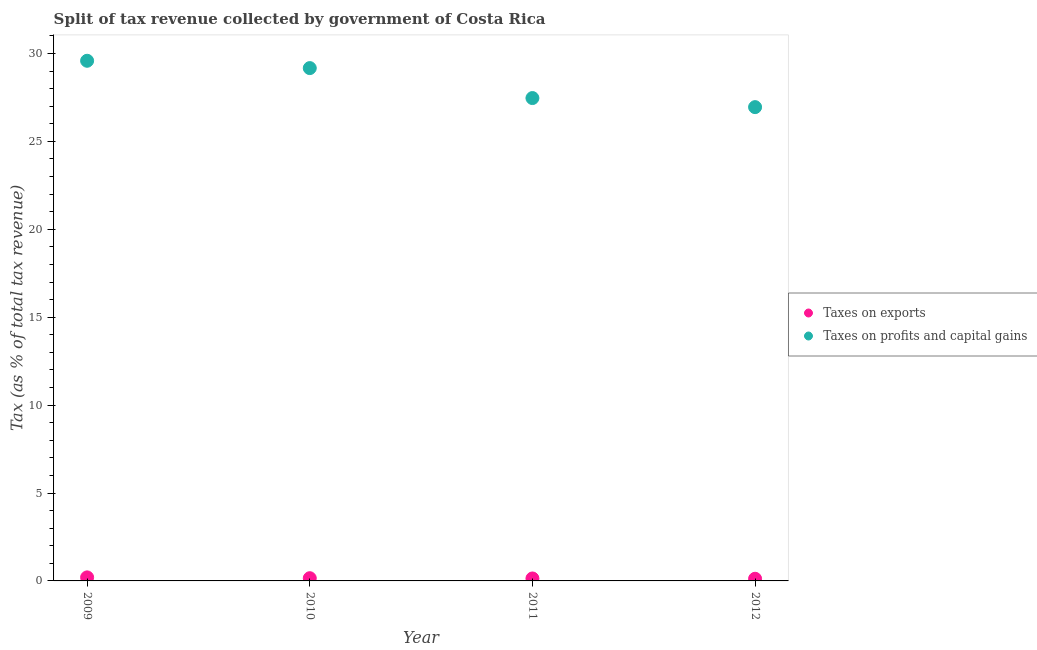How many different coloured dotlines are there?
Make the answer very short. 2. What is the percentage of revenue obtained from taxes on exports in 2010?
Your response must be concise. 0.15. Across all years, what is the maximum percentage of revenue obtained from taxes on profits and capital gains?
Your answer should be compact. 29.58. Across all years, what is the minimum percentage of revenue obtained from taxes on profits and capital gains?
Provide a succinct answer. 26.95. In which year was the percentage of revenue obtained from taxes on exports minimum?
Your answer should be very brief. 2012. What is the total percentage of revenue obtained from taxes on profits and capital gains in the graph?
Offer a very short reply. 113.16. What is the difference between the percentage of revenue obtained from taxes on exports in 2009 and that in 2011?
Your response must be concise. 0.06. What is the difference between the percentage of revenue obtained from taxes on profits and capital gains in 2011 and the percentage of revenue obtained from taxes on exports in 2012?
Your answer should be compact. 27.34. What is the average percentage of revenue obtained from taxes on profits and capital gains per year?
Keep it short and to the point. 28.29. In the year 2009, what is the difference between the percentage of revenue obtained from taxes on exports and percentage of revenue obtained from taxes on profits and capital gains?
Offer a very short reply. -29.38. In how many years, is the percentage of revenue obtained from taxes on exports greater than 27 %?
Provide a short and direct response. 0. What is the ratio of the percentage of revenue obtained from taxes on profits and capital gains in 2009 to that in 2012?
Make the answer very short. 1.1. What is the difference between the highest and the second highest percentage of revenue obtained from taxes on profits and capital gains?
Offer a very short reply. 0.42. What is the difference between the highest and the lowest percentage of revenue obtained from taxes on exports?
Your answer should be compact. 0.08. In how many years, is the percentage of revenue obtained from taxes on exports greater than the average percentage of revenue obtained from taxes on exports taken over all years?
Ensure brevity in your answer.  2. Is the sum of the percentage of revenue obtained from taxes on profits and capital gains in 2010 and 2011 greater than the maximum percentage of revenue obtained from taxes on exports across all years?
Ensure brevity in your answer.  Yes. Does the percentage of revenue obtained from taxes on exports monotonically increase over the years?
Your answer should be compact. No. Is the percentage of revenue obtained from taxes on exports strictly greater than the percentage of revenue obtained from taxes on profits and capital gains over the years?
Your answer should be very brief. No. Does the graph contain any zero values?
Offer a very short reply. No. How many legend labels are there?
Provide a short and direct response. 2. How are the legend labels stacked?
Offer a very short reply. Vertical. What is the title of the graph?
Your answer should be compact. Split of tax revenue collected by government of Costa Rica. What is the label or title of the X-axis?
Provide a succinct answer. Year. What is the label or title of the Y-axis?
Keep it short and to the point. Tax (as % of total tax revenue). What is the Tax (as % of total tax revenue) of Taxes on exports in 2009?
Provide a short and direct response. 0.2. What is the Tax (as % of total tax revenue) of Taxes on profits and capital gains in 2009?
Give a very brief answer. 29.58. What is the Tax (as % of total tax revenue) of Taxes on exports in 2010?
Offer a terse response. 0.15. What is the Tax (as % of total tax revenue) of Taxes on profits and capital gains in 2010?
Provide a short and direct response. 29.17. What is the Tax (as % of total tax revenue) in Taxes on exports in 2011?
Ensure brevity in your answer.  0.14. What is the Tax (as % of total tax revenue) in Taxes on profits and capital gains in 2011?
Offer a very short reply. 27.46. What is the Tax (as % of total tax revenue) of Taxes on exports in 2012?
Offer a terse response. 0.12. What is the Tax (as % of total tax revenue) in Taxes on profits and capital gains in 2012?
Make the answer very short. 26.95. Across all years, what is the maximum Tax (as % of total tax revenue) in Taxes on exports?
Your answer should be very brief. 0.2. Across all years, what is the maximum Tax (as % of total tax revenue) of Taxes on profits and capital gains?
Give a very brief answer. 29.58. Across all years, what is the minimum Tax (as % of total tax revenue) in Taxes on exports?
Keep it short and to the point. 0.12. Across all years, what is the minimum Tax (as % of total tax revenue) of Taxes on profits and capital gains?
Keep it short and to the point. 26.95. What is the total Tax (as % of total tax revenue) in Taxes on exports in the graph?
Keep it short and to the point. 0.62. What is the total Tax (as % of total tax revenue) in Taxes on profits and capital gains in the graph?
Ensure brevity in your answer.  113.16. What is the difference between the Tax (as % of total tax revenue) in Taxes on exports in 2009 and that in 2010?
Your answer should be compact. 0.05. What is the difference between the Tax (as % of total tax revenue) of Taxes on profits and capital gains in 2009 and that in 2010?
Offer a terse response. 0.42. What is the difference between the Tax (as % of total tax revenue) of Taxes on exports in 2009 and that in 2011?
Your answer should be compact. 0.06. What is the difference between the Tax (as % of total tax revenue) in Taxes on profits and capital gains in 2009 and that in 2011?
Provide a short and direct response. 2.12. What is the difference between the Tax (as % of total tax revenue) in Taxes on exports in 2009 and that in 2012?
Offer a very short reply. 0.08. What is the difference between the Tax (as % of total tax revenue) of Taxes on profits and capital gains in 2009 and that in 2012?
Offer a very short reply. 2.64. What is the difference between the Tax (as % of total tax revenue) of Taxes on exports in 2010 and that in 2011?
Your response must be concise. 0.02. What is the difference between the Tax (as % of total tax revenue) of Taxes on profits and capital gains in 2010 and that in 2011?
Keep it short and to the point. 1.7. What is the difference between the Tax (as % of total tax revenue) in Taxes on exports in 2010 and that in 2012?
Provide a short and direct response. 0.03. What is the difference between the Tax (as % of total tax revenue) in Taxes on profits and capital gains in 2010 and that in 2012?
Ensure brevity in your answer.  2.22. What is the difference between the Tax (as % of total tax revenue) in Taxes on exports in 2011 and that in 2012?
Provide a succinct answer. 0.02. What is the difference between the Tax (as % of total tax revenue) of Taxes on profits and capital gains in 2011 and that in 2012?
Your answer should be compact. 0.52. What is the difference between the Tax (as % of total tax revenue) of Taxes on exports in 2009 and the Tax (as % of total tax revenue) of Taxes on profits and capital gains in 2010?
Offer a terse response. -28.97. What is the difference between the Tax (as % of total tax revenue) of Taxes on exports in 2009 and the Tax (as % of total tax revenue) of Taxes on profits and capital gains in 2011?
Provide a succinct answer. -27.26. What is the difference between the Tax (as % of total tax revenue) in Taxes on exports in 2009 and the Tax (as % of total tax revenue) in Taxes on profits and capital gains in 2012?
Give a very brief answer. -26.75. What is the difference between the Tax (as % of total tax revenue) of Taxes on exports in 2010 and the Tax (as % of total tax revenue) of Taxes on profits and capital gains in 2011?
Your answer should be compact. -27.31. What is the difference between the Tax (as % of total tax revenue) in Taxes on exports in 2010 and the Tax (as % of total tax revenue) in Taxes on profits and capital gains in 2012?
Provide a succinct answer. -26.79. What is the difference between the Tax (as % of total tax revenue) of Taxes on exports in 2011 and the Tax (as % of total tax revenue) of Taxes on profits and capital gains in 2012?
Make the answer very short. -26.81. What is the average Tax (as % of total tax revenue) of Taxes on exports per year?
Make the answer very short. 0.15. What is the average Tax (as % of total tax revenue) of Taxes on profits and capital gains per year?
Provide a short and direct response. 28.29. In the year 2009, what is the difference between the Tax (as % of total tax revenue) of Taxes on exports and Tax (as % of total tax revenue) of Taxes on profits and capital gains?
Give a very brief answer. -29.38. In the year 2010, what is the difference between the Tax (as % of total tax revenue) in Taxes on exports and Tax (as % of total tax revenue) in Taxes on profits and capital gains?
Offer a very short reply. -29.01. In the year 2011, what is the difference between the Tax (as % of total tax revenue) in Taxes on exports and Tax (as % of total tax revenue) in Taxes on profits and capital gains?
Your answer should be compact. -27.32. In the year 2012, what is the difference between the Tax (as % of total tax revenue) in Taxes on exports and Tax (as % of total tax revenue) in Taxes on profits and capital gains?
Offer a terse response. -26.82. What is the ratio of the Tax (as % of total tax revenue) of Taxes on exports in 2009 to that in 2010?
Your response must be concise. 1.3. What is the ratio of the Tax (as % of total tax revenue) in Taxes on profits and capital gains in 2009 to that in 2010?
Ensure brevity in your answer.  1.01. What is the ratio of the Tax (as % of total tax revenue) of Taxes on exports in 2009 to that in 2011?
Ensure brevity in your answer.  1.44. What is the ratio of the Tax (as % of total tax revenue) in Taxes on profits and capital gains in 2009 to that in 2011?
Provide a short and direct response. 1.08. What is the ratio of the Tax (as % of total tax revenue) of Taxes on exports in 2009 to that in 2012?
Your answer should be very brief. 1.64. What is the ratio of the Tax (as % of total tax revenue) of Taxes on profits and capital gains in 2009 to that in 2012?
Your response must be concise. 1.1. What is the ratio of the Tax (as % of total tax revenue) of Taxes on exports in 2010 to that in 2011?
Your response must be concise. 1.11. What is the ratio of the Tax (as % of total tax revenue) of Taxes on profits and capital gains in 2010 to that in 2011?
Keep it short and to the point. 1.06. What is the ratio of the Tax (as % of total tax revenue) in Taxes on exports in 2010 to that in 2012?
Your answer should be very brief. 1.26. What is the ratio of the Tax (as % of total tax revenue) of Taxes on profits and capital gains in 2010 to that in 2012?
Offer a terse response. 1.08. What is the ratio of the Tax (as % of total tax revenue) of Taxes on exports in 2011 to that in 2012?
Make the answer very short. 1.14. What is the ratio of the Tax (as % of total tax revenue) in Taxes on profits and capital gains in 2011 to that in 2012?
Make the answer very short. 1.02. What is the difference between the highest and the second highest Tax (as % of total tax revenue) in Taxes on exports?
Provide a short and direct response. 0.05. What is the difference between the highest and the second highest Tax (as % of total tax revenue) of Taxes on profits and capital gains?
Your response must be concise. 0.42. What is the difference between the highest and the lowest Tax (as % of total tax revenue) of Taxes on exports?
Your answer should be very brief. 0.08. What is the difference between the highest and the lowest Tax (as % of total tax revenue) in Taxes on profits and capital gains?
Your answer should be very brief. 2.64. 